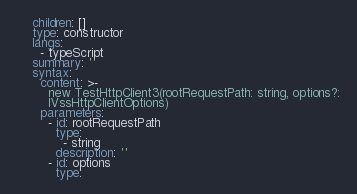Convert code to text. <code><loc_0><loc_0><loc_500><loc_500><_YAML_>    children: []
    type: constructor
    langs:
      - typeScript
    summary: ''
    syntax:
      content: >-
        new TestHttpClient3(rootRequestPath: string, options?:
        IVssHttpClientOptions)
      parameters:
        - id: rootRequestPath
          type:
            - string
          description: ''
        - id: options
          type:</code> 